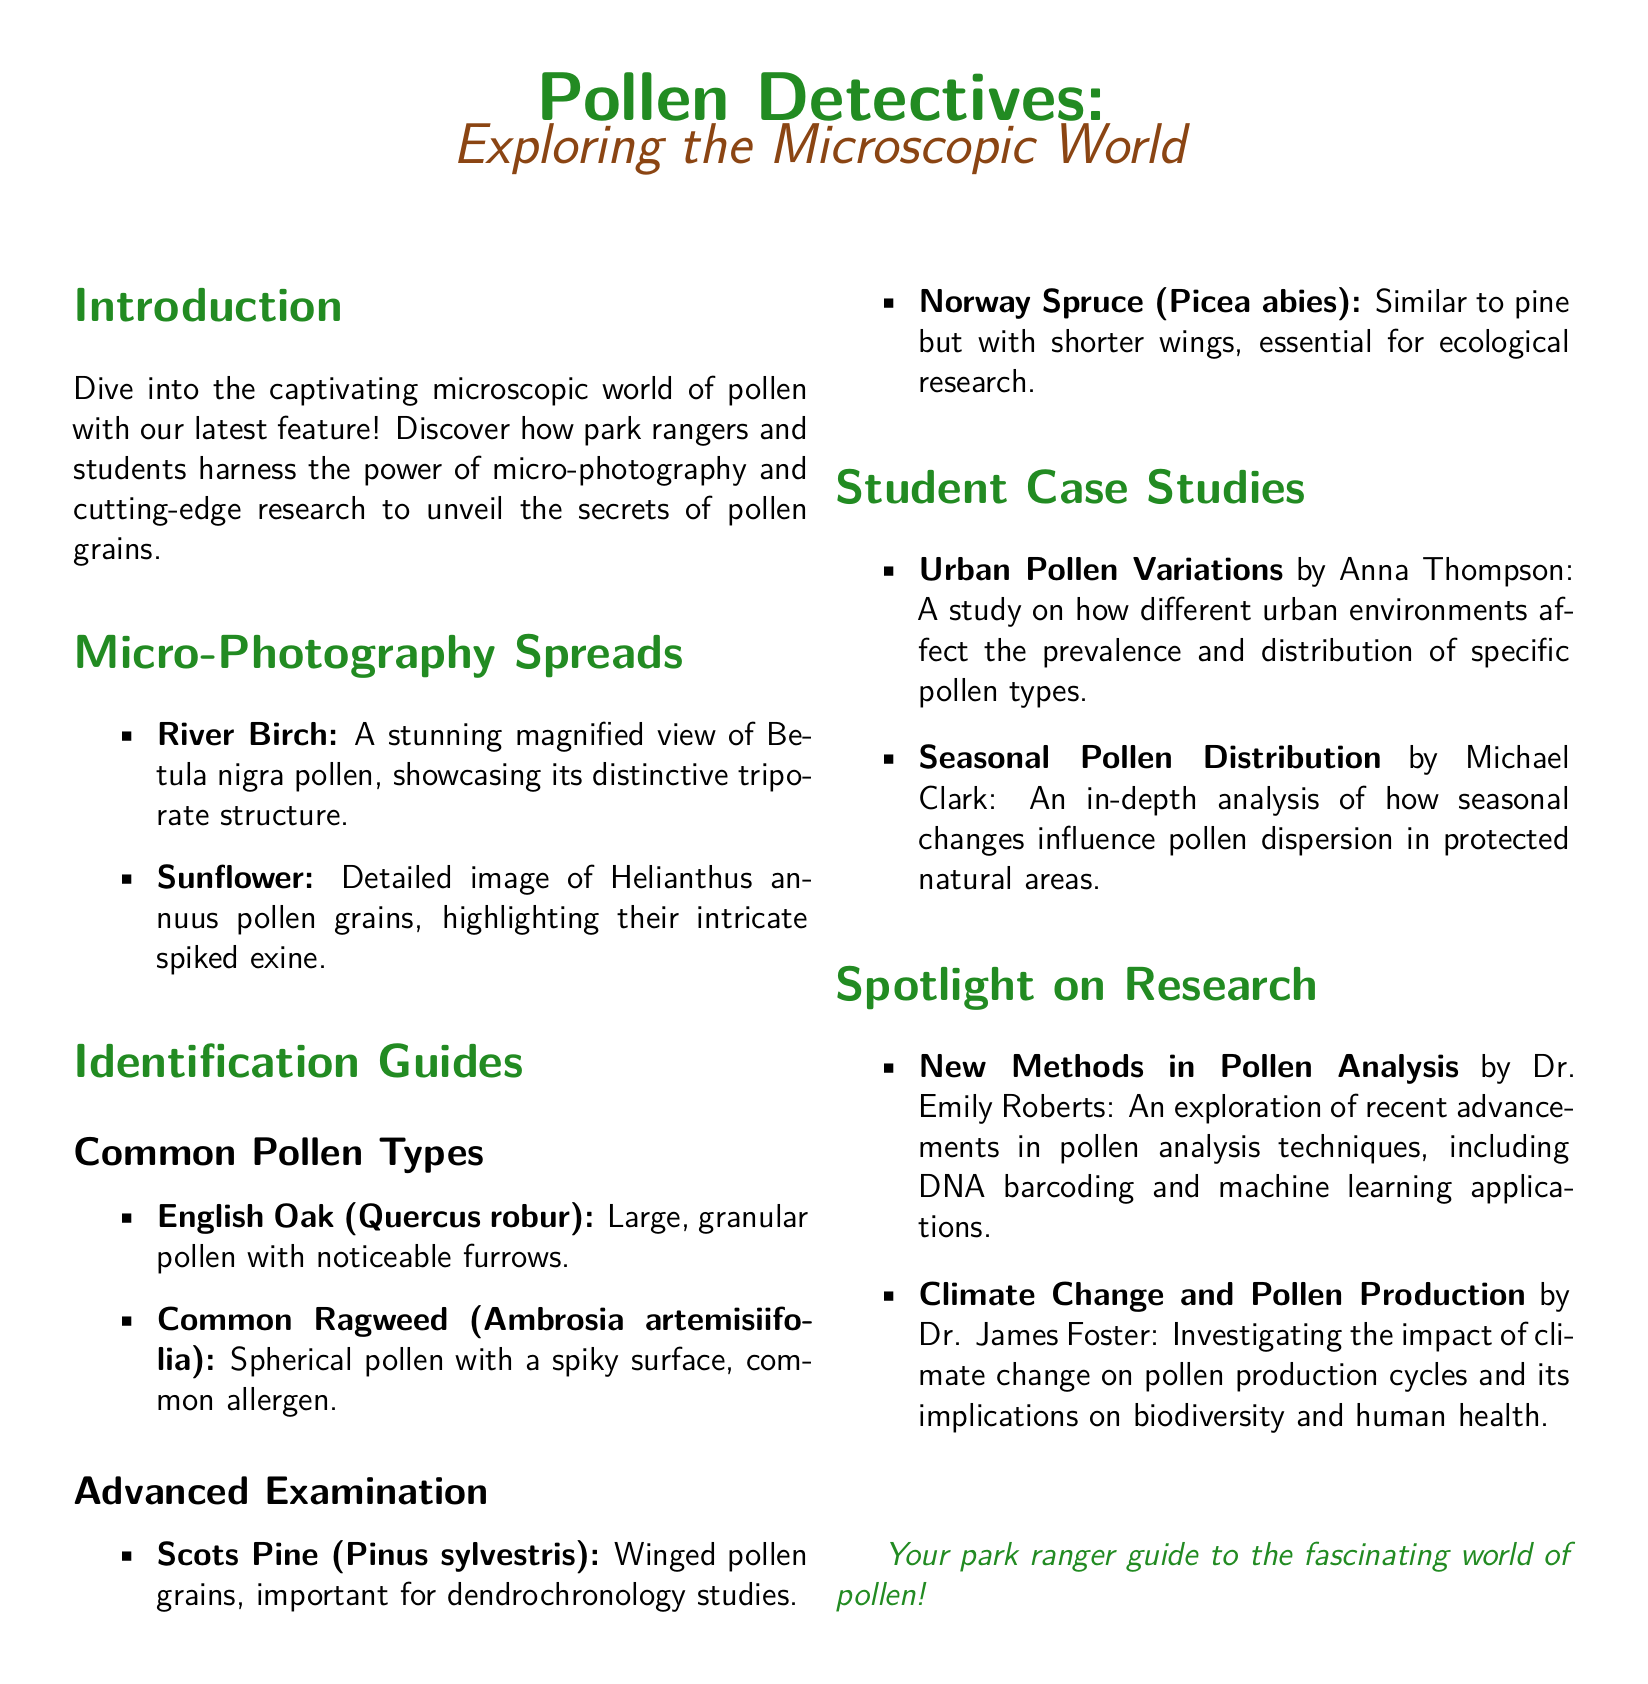What is the title of the feature? The title of the feature is stated prominently at the beginning of the document.
Answer: Pollen Detectives What is the main focus of the feature? The main focus of the feature is highlighted in the subtitle.
Answer: Exploring the Microscopic World Who authored the study on urban pollen variations? The document lists a student and their case study title related to urban pollen.
Answer: Anna Thompson What pollen type is a common allergen? The identification guide mentions a specific pollen known for causing allergies.
Answer: Common Ragweed What is the pollen type highlighted in the micro-photography spread of River Birch? This detail is found under the micro-photography section.
Answer: Betula nigra Which researcher explored climate change and pollen production? A specific researcher is mentioned in the spotlight section regarding climate change.
Answer: Dr. James Foster What advanced method in pollen analysis is discussed? The spotlight on research section covers recent advancements in pollen analysis.
Answer: DNA barcoding What structure characterizes the sunflower pollen? The micro-photography spread gives insight into the characteristics of sunflower pollen.
Answer: Intricate spiked exine 